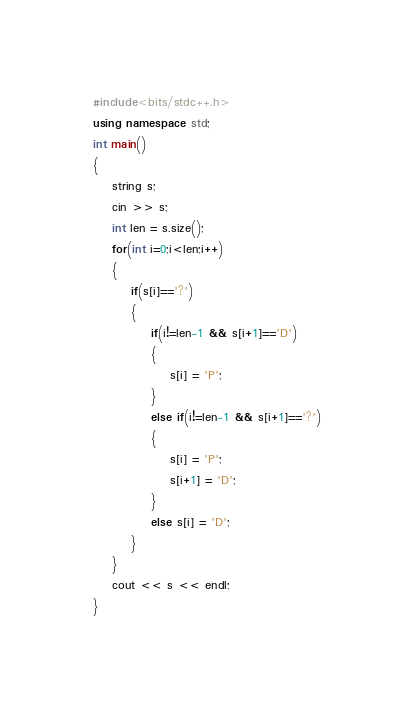Convert code to text. <code><loc_0><loc_0><loc_500><loc_500><_C++_>#include<bits/stdc++.h>
using namespace std;
int main()
{
    string s;
    cin >> s;
    int len = s.size();
    for(int i=0;i<len;i++)
    {
        if(s[i]=='?')
        {
            if(i!=len-1 && s[i+1]=='D')
            {
                s[i] = 'P';
            }
            else if(i!=len-1 && s[i+1]=='?')
            {
                s[i] = 'P';
                s[i+1] = 'D';
            }
            else s[i] = 'D';
        }
    }
    cout << s << endl;
}
</code> 